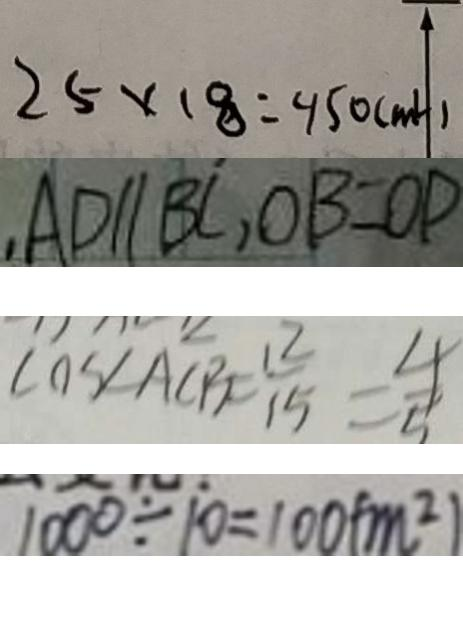<formula> <loc_0><loc_0><loc_500><loc_500>2 5 \times 1 8 = 4 5 0 ( m l ) 
 , A D / / B C , O B = O P 
 \cos \angle A C B = \frac { 1 2 } { 1 5 } = \frac { 4 } { 5 } 
 1 0 0 0 \div 1 0 = 1 0 0 ( m ^ { 2 } )</formula> 